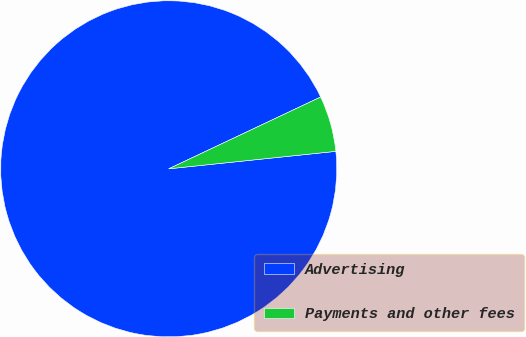Convert chart. <chart><loc_0><loc_0><loc_500><loc_500><pie_chart><fcel>Advertising<fcel>Payments and other fees<nl><fcel>94.63%<fcel>5.37%<nl></chart> 